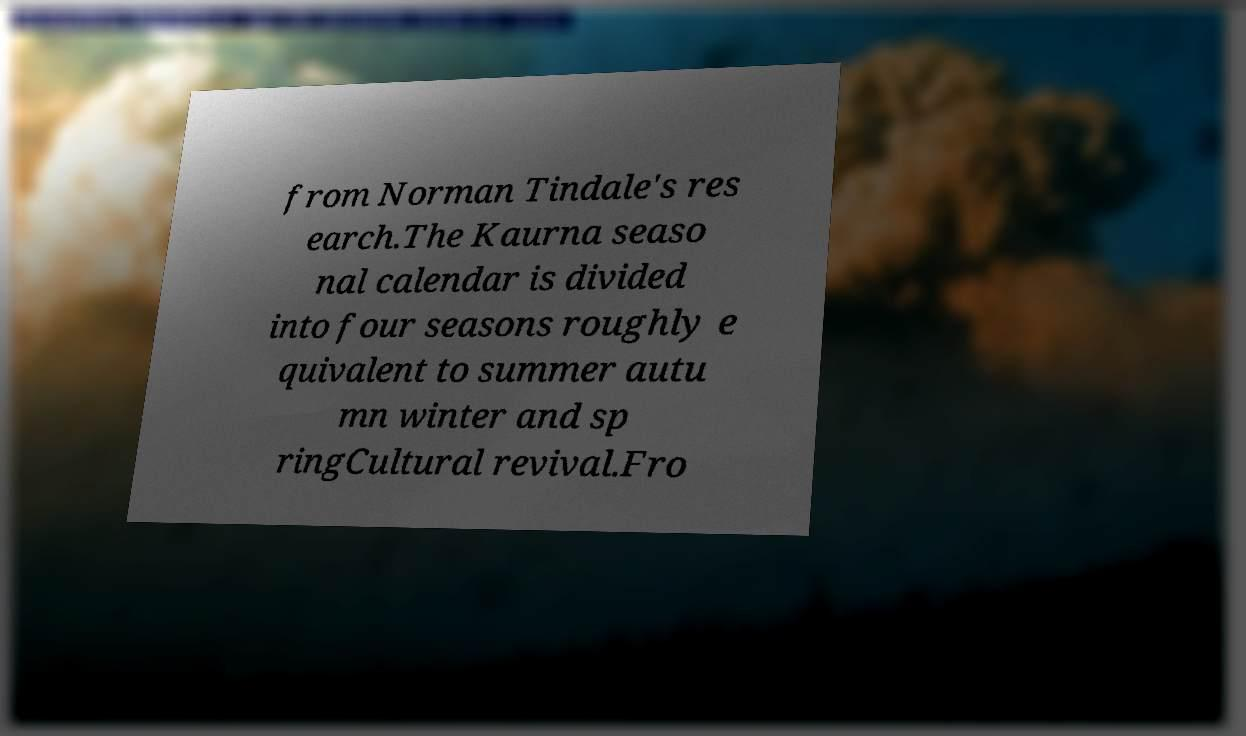Please identify and transcribe the text found in this image. from Norman Tindale's res earch.The Kaurna seaso nal calendar is divided into four seasons roughly e quivalent to summer autu mn winter and sp ringCultural revival.Fro 